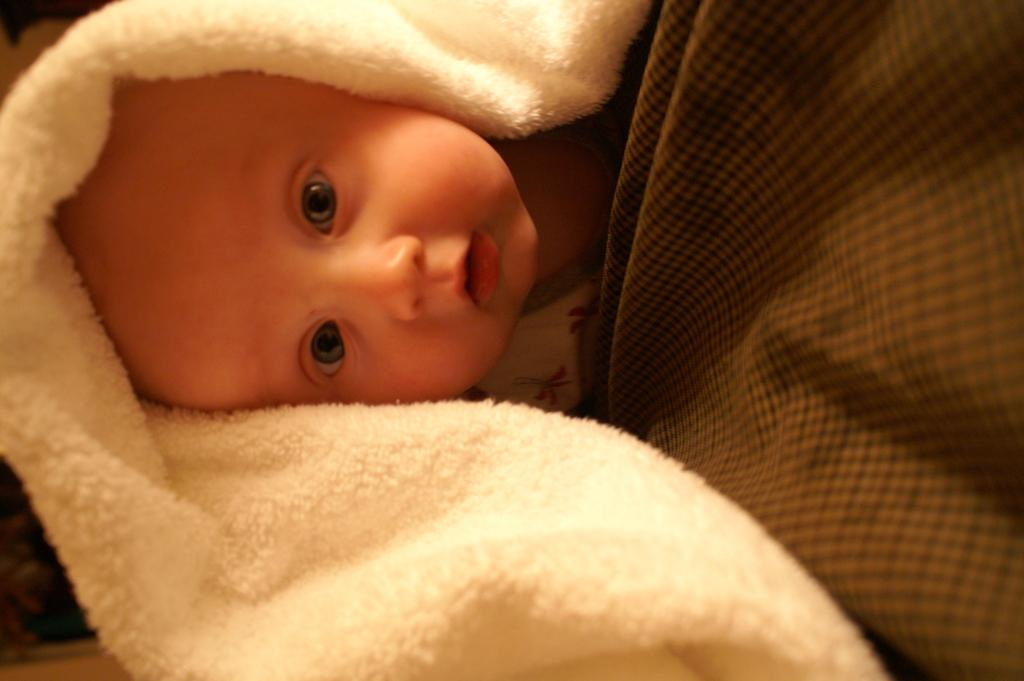What is the main subject of the image? The main subject of the image is a kid. What can be seen on the left side of the image? There is a tower on the left side of the image. What is on the right side of the image? There is a cloth on the right side of the image. What type of advice can be seen written on the cloth in the image? There is no advice written on the cloth in the image; it is just a cloth. Can you see any mist in the image? There is no mist present in the image. 